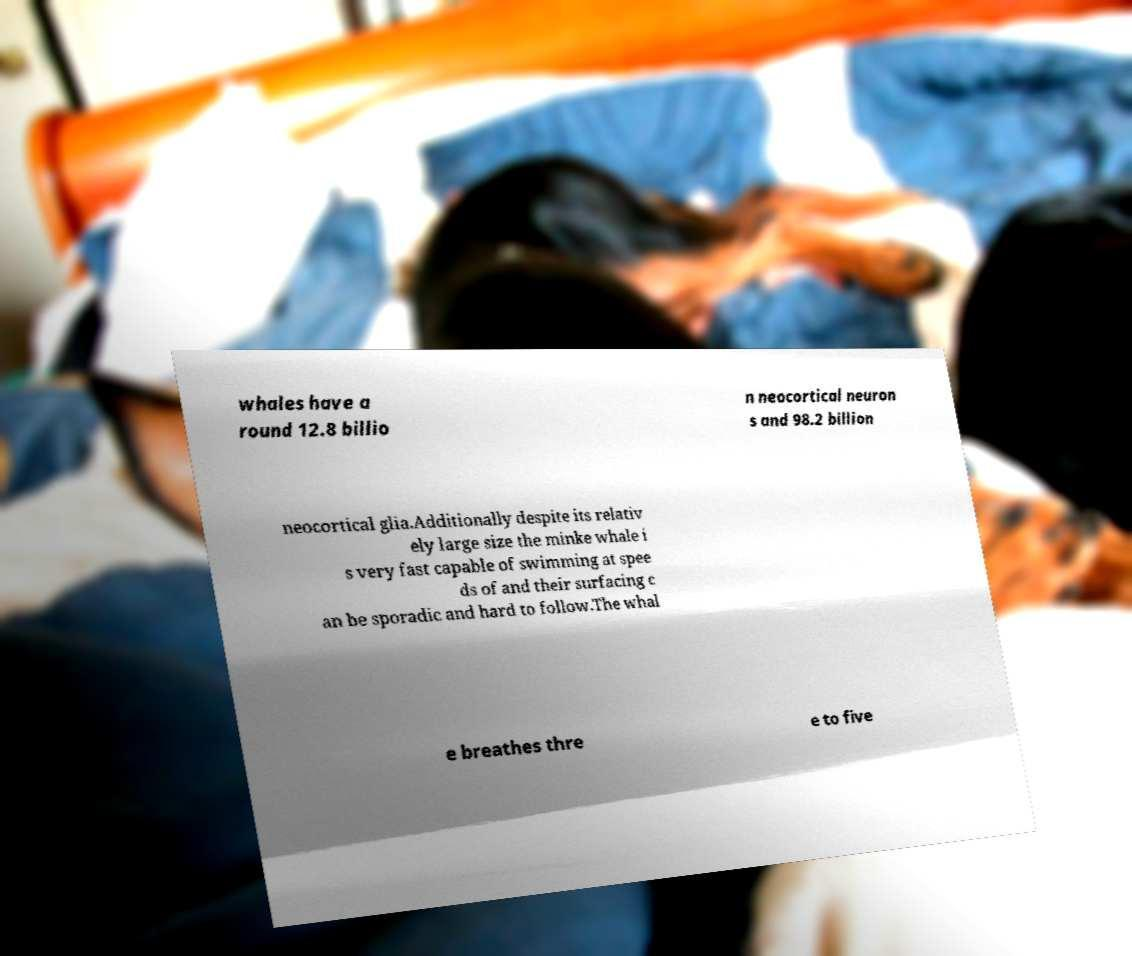Can you read and provide the text displayed in the image?This photo seems to have some interesting text. Can you extract and type it out for me? whales have a round 12.8 billio n neocortical neuron s and 98.2 billion neocortical glia.Additionally despite its relativ ely large size the minke whale i s very fast capable of swimming at spee ds of and their surfacing c an be sporadic and hard to follow.The whal e breathes thre e to five 